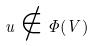Convert formula to latex. <formula><loc_0><loc_0><loc_500><loc_500>u \notin \Phi ( V )</formula> 